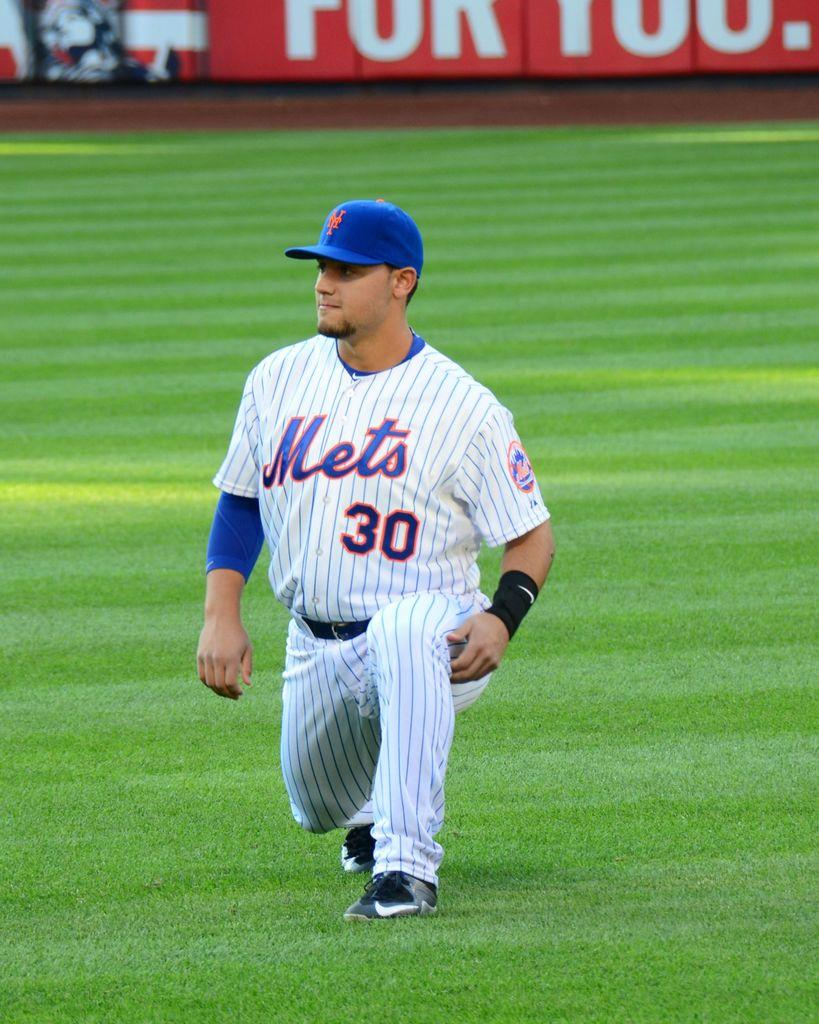Provide a one-sentence caption for the provided image. A Mets baseball player number 30 stretches his hamstring. 